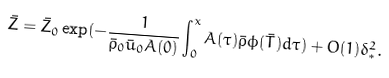<formula> <loc_0><loc_0><loc_500><loc_500>& \bar { Z } = \bar { Z } _ { 0 } \exp ( - \frac { 1 } { \bar { \rho } _ { 0 } \bar { u } _ { 0 } A ( 0 ) } \int _ { 0 } ^ { x } A ( \tau ) \bar { \rho } \phi ( \bar { T } ) d \tau ) + O ( 1 ) \delta _ { * } ^ { 2 } .</formula> 